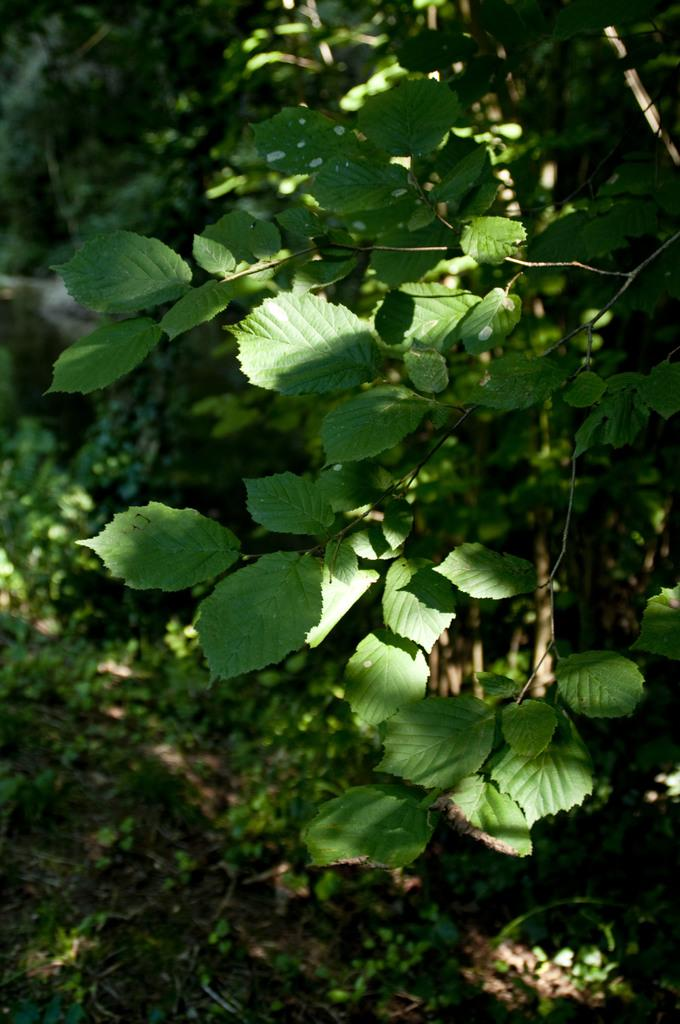What type of living organisms can be seen in the image? There is a group of plants in the image. What type of fuel is being used in the lunchroom depicted in the image? There is no lunchroom or fuel present in the image; it only features a group of plants. 